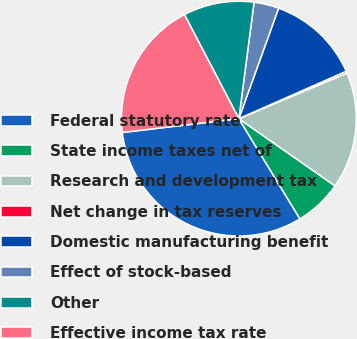Convert chart. <chart><loc_0><loc_0><loc_500><loc_500><pie_chart><fcel>Federal statutory rate<fcel>State income taxes net of<fcel>Research and development tax<fcel>Net change in tax reserves<fcel>Domestic manufacturing benefit<fcel>Effect of stock-based<fcel>Other<fcel>Effective income tax rate<nl><fcel>31.83%<fcel>6.58%<fcel>16.05%<fcel>0.27%<fcel>12.89%<fcel>3.43%<fcel>9.74%<fcel>19.21%<nl></chart> 